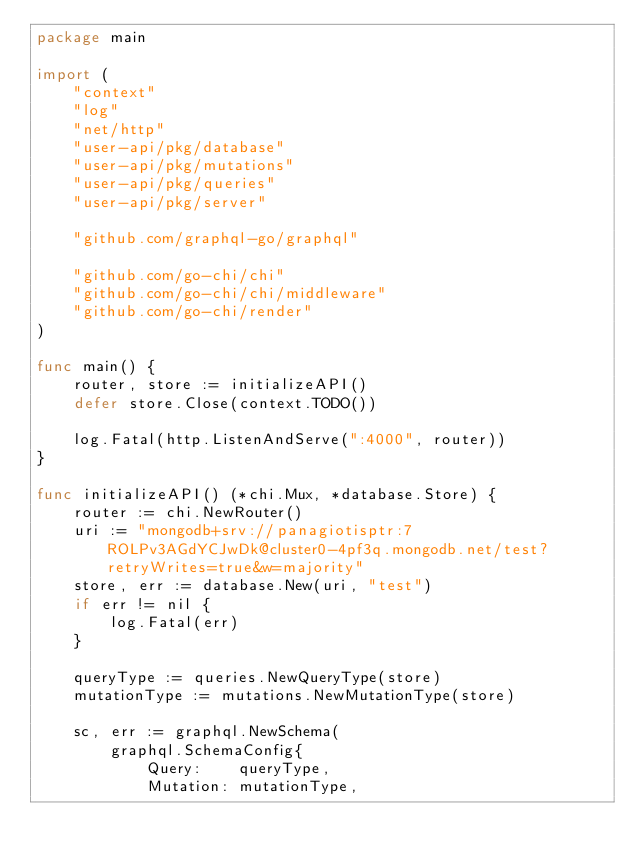Convert code to text. <code><loc_0><loc_0><loc_500><loc_500><_Go_>package main

import (
	"context"
	"log"
	"net/http"
	"user-api/pkg/database"
	"user-api/pkg/mutations"
	"user-api/pkg/queries"
	"user-api/pkg/server"

	"github.com/graphql-go/graphql"

	"github.com/go-chi/chi"
	"github.com/go-chi/chi/middleware"
	"github.com/go-chi/render"
)

func main() {
	router, store := initializeAPI()
	defer store.Close(context.TODO())

	log.Fatal(http.ListenAndServe(":4000", router))
}

func initializeAPI() (*chi.Mux, *database.Store) {
	router := chi.NewRouter()
	uri := "mongodb+srv://panagiotisptr:7ROLPv3AGdYCJwDk@cluster0-4pf3q.mongodb.net/test?retryWrites=true&w=majority"
	store, err := database.New(uri, "test")
	if err != nil {
		log.Fatal(err)
	}

	queryType := queries.NewQueryType(store)
	mutationType := mutations.NewMutationType(store)

	sc, err := graphql.NewSchema(
		graphql.SchemaConfig{
			Query:    queryType,
			Mutation: mutationType,</code> 